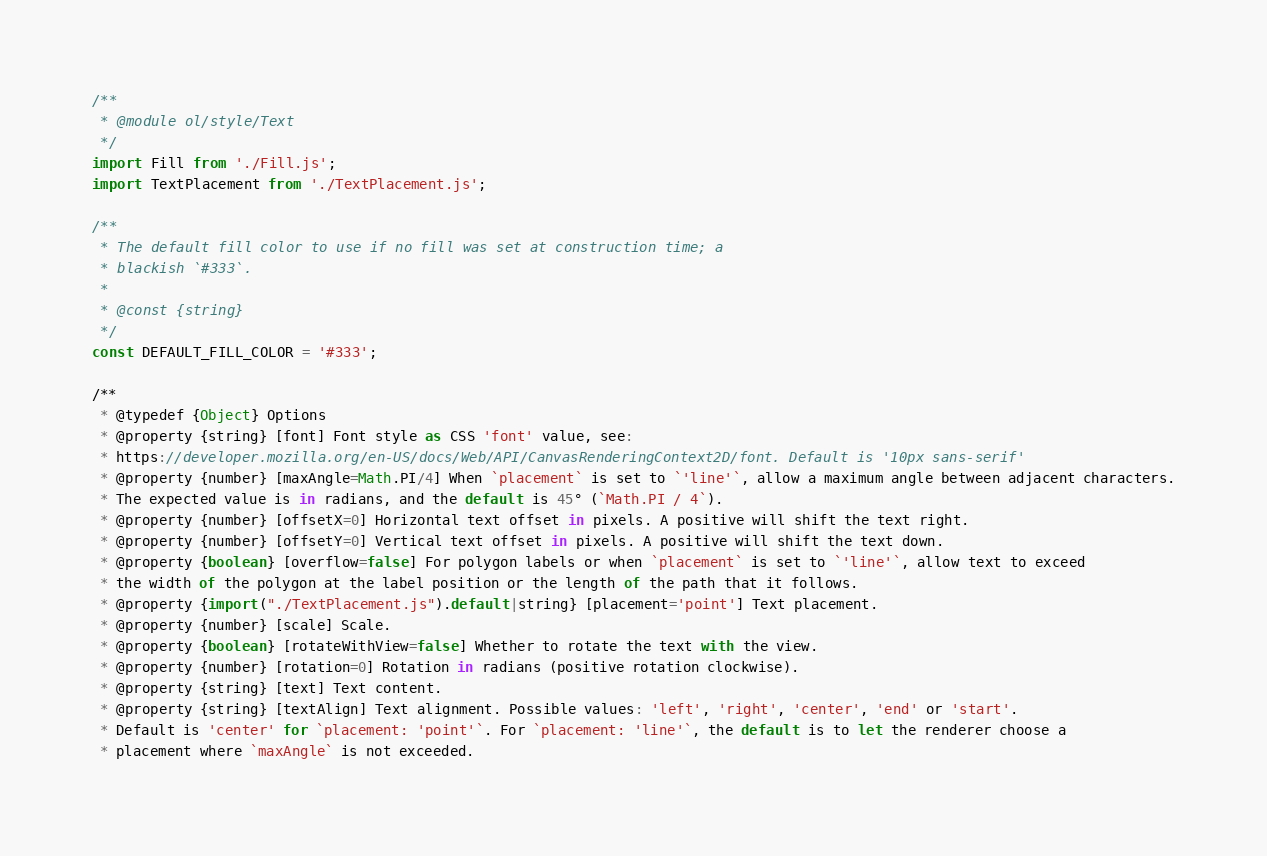Convert code to text. <code><loc_0><loc_0><loc_500><loc_500><_JavaScript_>/**
 * @module ol/style/Text
 */
import Fill from './Fill.js';
import TextPlacement from './TextPlacement.js';

/**
 * The default fill color to use if no fill was set at construction time; a
 * blackish `#333`.
 *
 * @const {string}
 */
const DEFAULT_FILL_COLOR = '#333';

/**
 * @typedef {Object} Options
 * @property {string} [font] Font style as CSS 'font' value, see:
 * https://developer.mozilla.org/en-US/docs/Web/API/CanvasRenderingContext2D/font. Default is '10px sans-serif'
 * @property {number} [maxAngle=Math.PI/4] When `placement` is set to `'line'`, allow a maximum angle between adjacent characters.
 * The expected value is in radians, and the default is 45° (`Math.PI / 4`).
 * @property {number} [offsetX=0] Horizontal text offset in pixels. A positive will shift the text right.
 * @property {number} [offsetY=0] Vertical text offset in pixels. A positive will shift the text down.
 * @property {boolean} [overflow=false] For polygon labels or when `placement` is set to `'line'`, allow text to exceed
 * the width of the polygon at the label position or the length of the path that it follows.
 * @property {import("./TextPlacement.js").default|string} [placement='point'] Text placement.
 * @property {number} [scale] Scale.
 * @property {boolean} [rotateWithView=false] Whether to rotate the text with the view.
 * @property {number} [rotation=0] Rotation in radians (positive rotation clockwise).
 * @property {string} [text] Text content.
 * @property {string} [textAlign] Text alignment. Possible values: 'left', 'right', 'center', 'end' or 'start'.
 * Default is 'center' for `placement: 'point'`. For `placement: 'line'`, the default is to let the renderer choose a
 * placement where `maxAngle` is not exceeded.</code> 